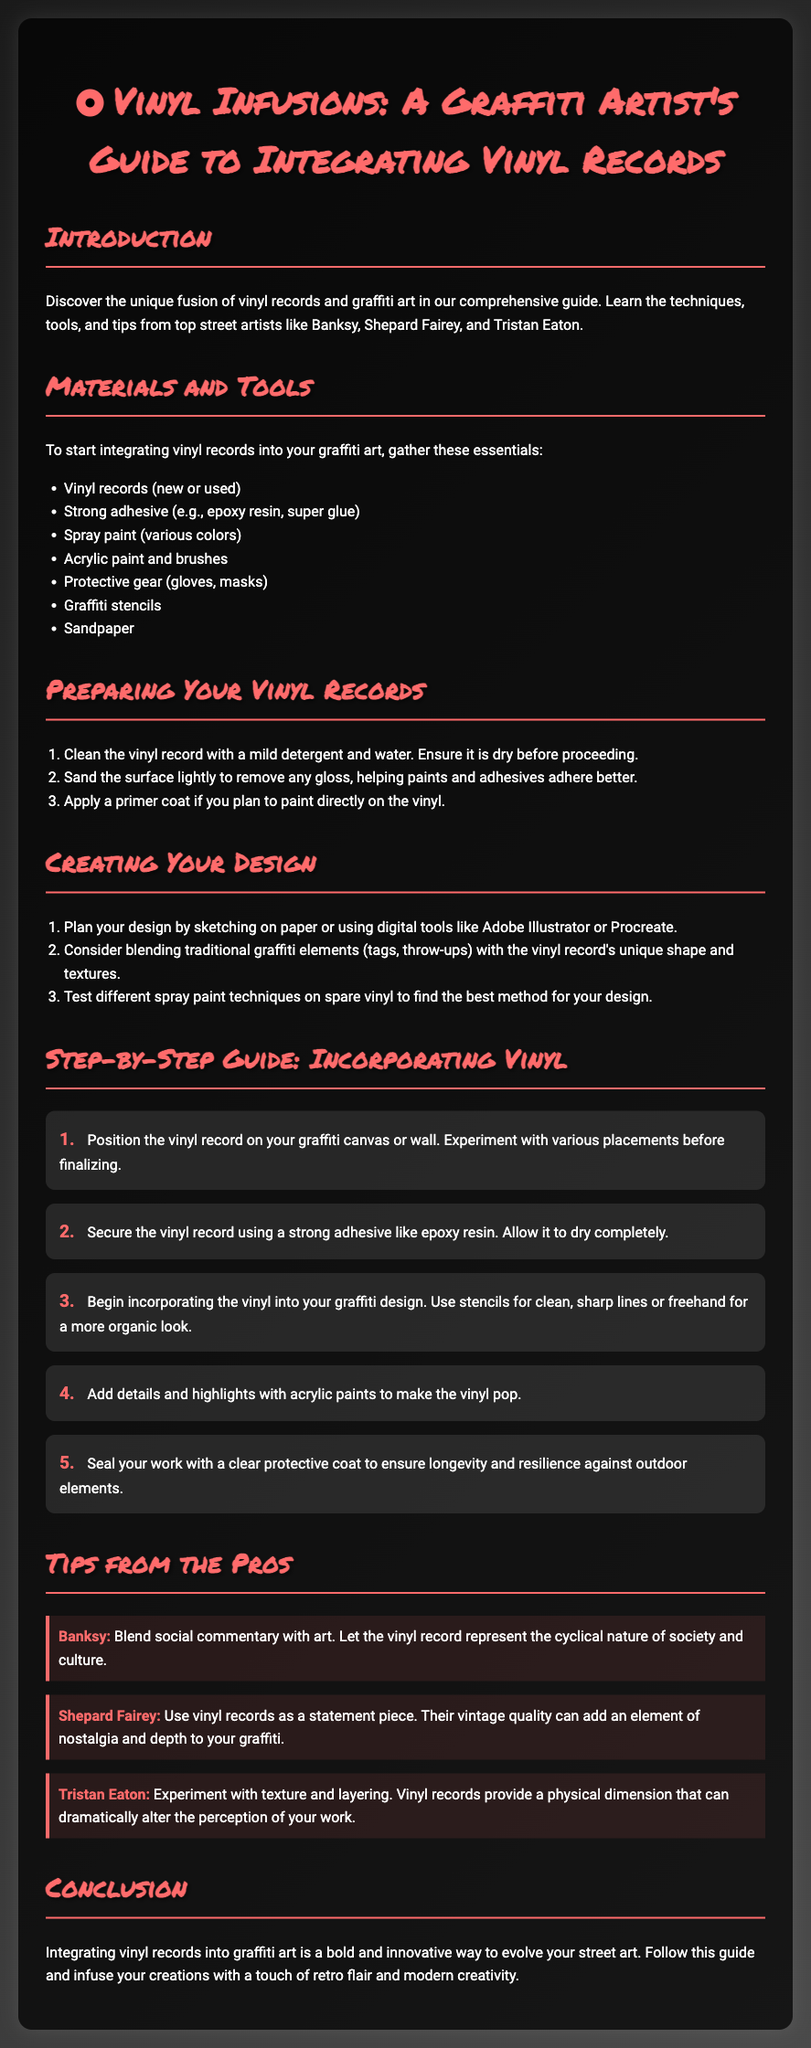What is the title of the booklet? The title is stated at the top of the document in a prominent way, indicating the subject of the guide.
Answer: Vinyl Infusions: A Graffiti Artist's Guide to Integrating Vinyl Records Who is cited as providing tips about blending social commentary with art? The document mentions a specific professional street artist who shares insights on this topic.
Answer: Banksy How many materials are listed for integrating vinyl records into graffiti art? The document includes a list of necessary materials for this integration, which can be counted.
Answer: 7 What is the first step in preparing your vinyl records? The first action item in the list related to preparing vinyl records is specifically highlighted.
Answer: Clean the vinyl record with a mild detergent and water Which street artist emphasizes experimenting with texture and layering? The document attributes specific advice to a well-known graffiti artist regarding texture and layering in art.
Answer: Tristan Eaton What type of protective gear is suggested in the materials section? Protective gear is mentioned as an important part of preparation, indicating items needed for safety.
Answer: Gloves, masks How many steps are there in the step-by-step guide for incorporating vinyl? The steps provided in the guide outline actions to follow, and can be counted for clarity.
Answer: 5 What technique does Shepard Fairey suggest using vinyl records for? The document specifies a stylistic approach suggested by this artist for utilizing vinyl records in artwork.
Answer: Statement piece 